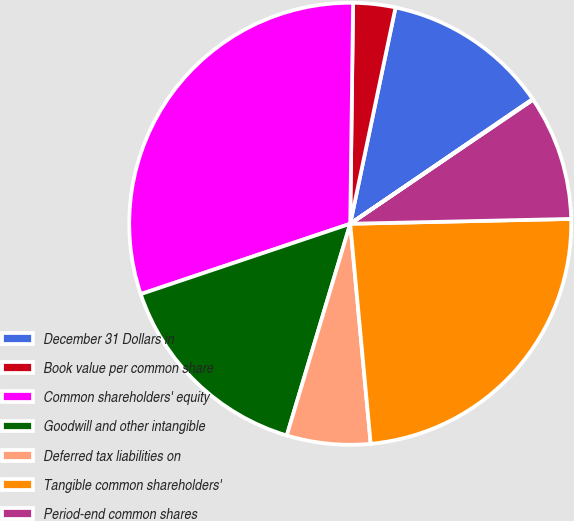Convert chart to OTSL. <chart><loc_0><loc_0><loc_500><loc_500><pie_chart><fcel>December 31 Dollars in<fcel>Book value per common share<fcel>Common shareholders' equity<fcel>Goodwill and other intangible<fcel>Deferred tax liabilities on<fcel>Tangible common shareholders'<fcel>Period-end common shares<fcel>Tangible book value per common<nl><fcel>12.17%<fcel>3.08%<fcel>30.36%<fcel>15.21%<fcel>6.11%<fcel>23.87%<fcel>9.14%<fcel>0.05%<nl></chart> 